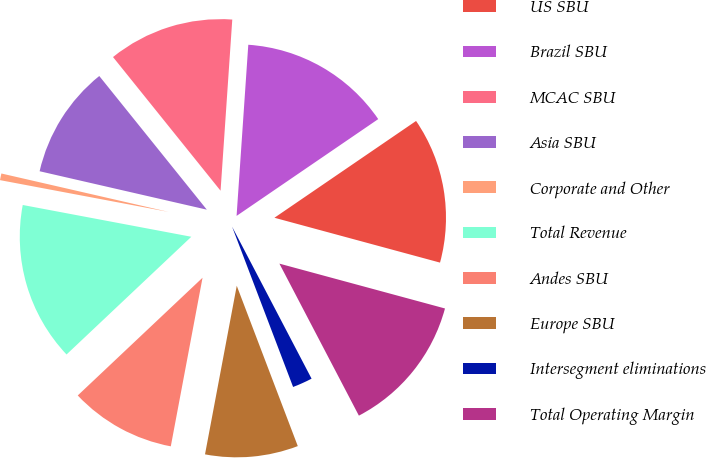Convert chart to OTSL. <chart><loc_0><loc_0><loc_500><loc_500><pie_chart><fcel>US SBU<fcel>Brazil SBU<fcel>MCAC SBU<fcel>Asia SBU<fcel>Corporate and Other<fcel>Total Revenue<fcel>Andes SBU<fcel>Europe SBU<fcel>Intersegment eliminations<fcel>Total Operating Margin<nl><fcel>13.75%<fcel>14.37%<fcel>11.87%<fcel>10.62%<fcel>0.63%<fcel>15.0%<fcel>10.0%<fcel>8.75%<fcel>1.88%<fcel>13.12%<nl></chart> 